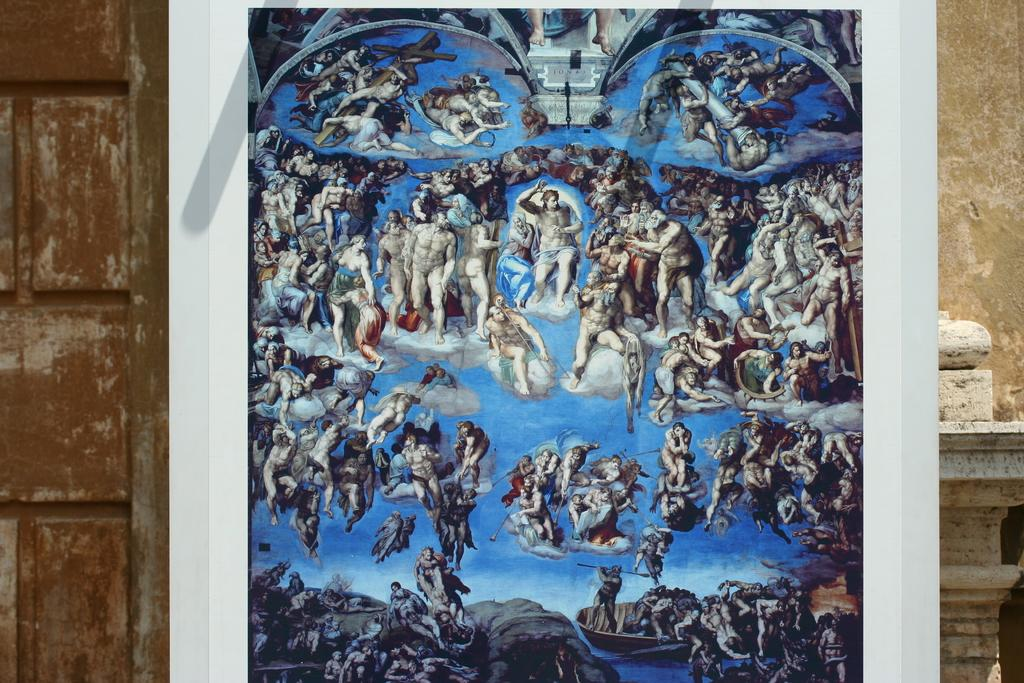Who or what can be seen in the image? There are people in the image. What is on the whiteboard in the image? There are objects on a whiteboard in the image. What can be seen in the background of the image? There is a wall in the background of the image. What type of dress is hanging on the shelf in the image? There is no dress or shelf present in the image. What is the purpose of the meeting taking place in the image? There is no indication of a meeting taking place in the image. 